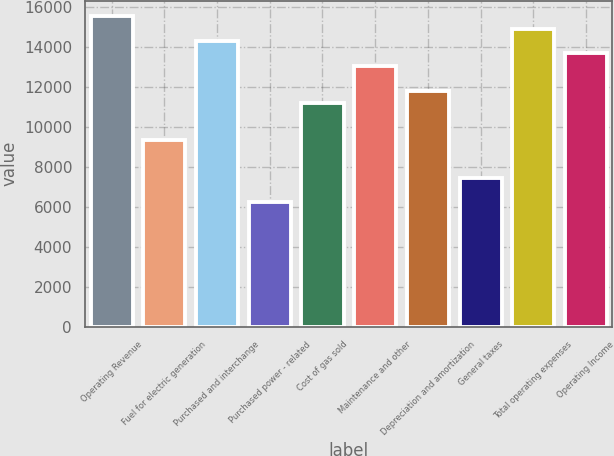Convert chart to OTSL. <chart><loc_0><loc_0><loc_500><loc_500><bar_chart><fcel>Operating Revenue<fcel>Fuel for electric generation<fcel>Purchased and interchange<fcel>Purchased power - related<fcel>Cost of gas sold<fcel>Maintenance and other<fcel>Depreciation and amortization<fcel>General taxes<fcel>Total operating expenses<fcel>Operating Income<nl><fcel>15553.5<fcel>9332.5<fcel>14309.3<fcel>6222<fcel>11198.8<fcel>13065.1<fcel>11820.9<fcel>7466.2<fcel>14931.4<fcel>13687.2<nl></chart> 